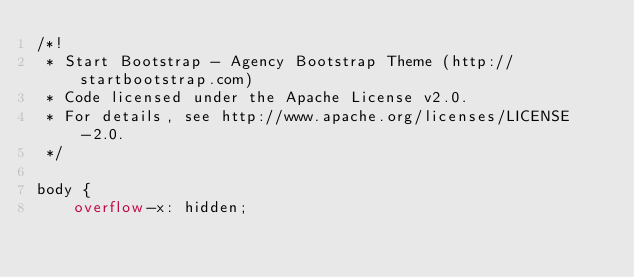Convert code to text. <code><loc_0><loc_0><loc_500><loc_500><_CSS_>/*!
 * Start Bootstrap - Agency Bootstrap Theme (http://startbootstrap.com)
 * Code licensed under the Apache License v2.0.
 * For details, see http://www.apache.org/licenses/LICENSE-2.0.
 */

body {
    overflow-x: hidden;</code> 